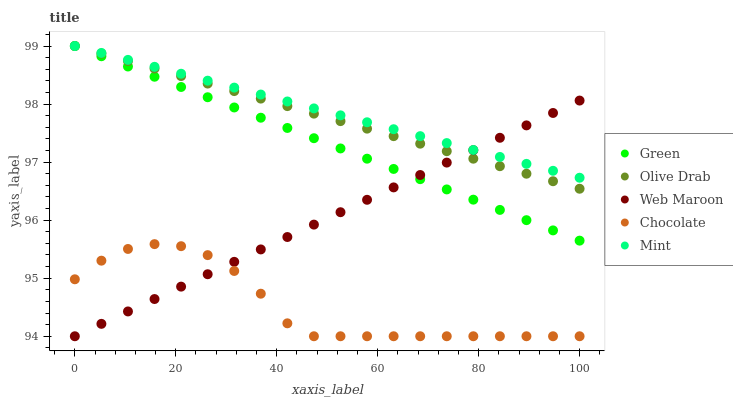Does Chocolate have the minimum area under the curve?
Answer yes or no. Yes. Does Mint have the maximum area under the curve?
Answer yes or no. Yes. Does Green have the minimum area under the curve?
Answer yes or no. No. Does Green have the maximum area under the curve?
Answer yes or no. No. Is Green the smoothest?
Answer yes or no. Yes. Is Chocolate the roughest?
Answer yes or no. Yes. Is Mint the smoothest?
Answer yes or no. No. Is Mint the roughest?
Answer yes or no. No. Does Web Maroon have the lowest value?
Answer yes or no. Yes. Does Green have the lowest value?
Answer yes or no. No. Does Olive Drab have the highest value?
Answer yes or no. Yes. Does Chocolate have the highest value?
Answer yes or no. No. Is Chocolate less than Mint?
Answer yes or no. Yes. Is Mint greater than Chocolate?
Answer yes or no. Yes. Does Mint intersect Olive Drab?
Answer yes or no. Yes. Is Mint less than Olive Drab?
Answer yes or no. No. Is Mint greater than Olive Drab?
Answer yes or no. No. Does Chocolate intersect Mint?
Answer yes or no. No. 